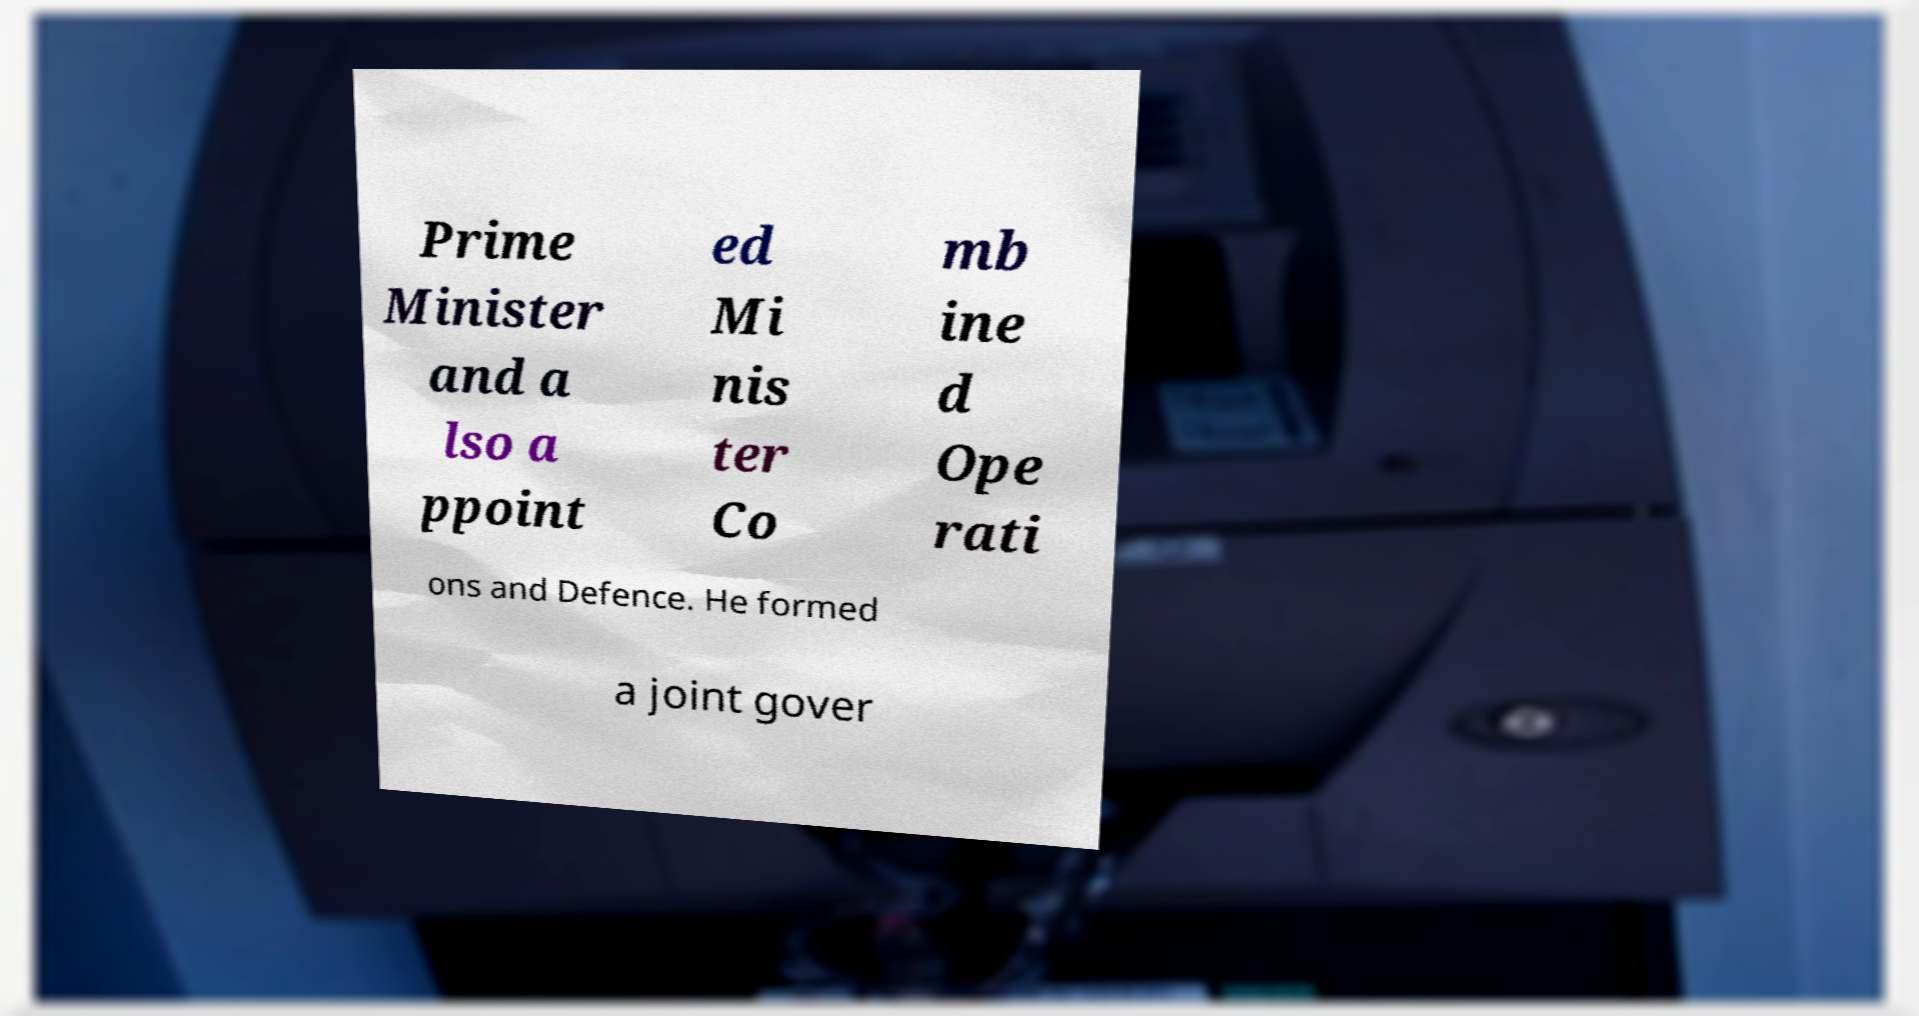What messages or text are displayed in this image? I need them in a readable, typed format. Prime Minister and a lso a ppoint ed Mi nis ter Co mb ine d Ope rati ons and Defence. He formed a joint gover 